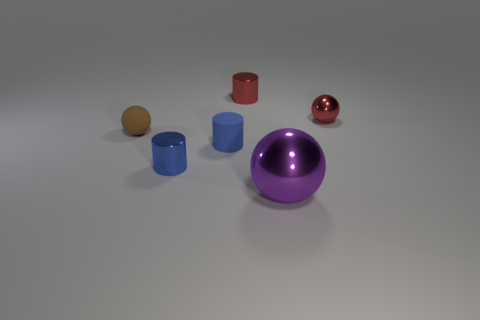There is a blue object that is made of the same material as the big sphere; what shape is it?
Your answer should be very brief. Cylinder. There is a tiny red thing on the left side of the tiny shiny sphere; what is its shape?
Offer a terse response. Cylinder. What is the color of the tiny metallic ball?
Make the answer very short. Red. How many other objects are there of the same size as the red cylinder?
Your answer should be compact. 4. There is a red object left of the small red metallic object that is right of the tiny red cylinder; what is its material?
Your response must be concise. Metal. There is a red metallic ball; is it the same size as the sphere that is left of the large ball?
Your answer should be very brief. Yes. Are there any small rubber objects of the same color as the small matte ball?
Provide a succinct answer. No. What is the material of the tiny red object that is on the left side of the purple object?
Your answer should be very brief. Metal. Are there any large balls to the right of the purple thing?
Give a very brief answer. No. Do the rubber cylinder and the red shiny ball have the same size?
Keep it short and to the point. Yes. 